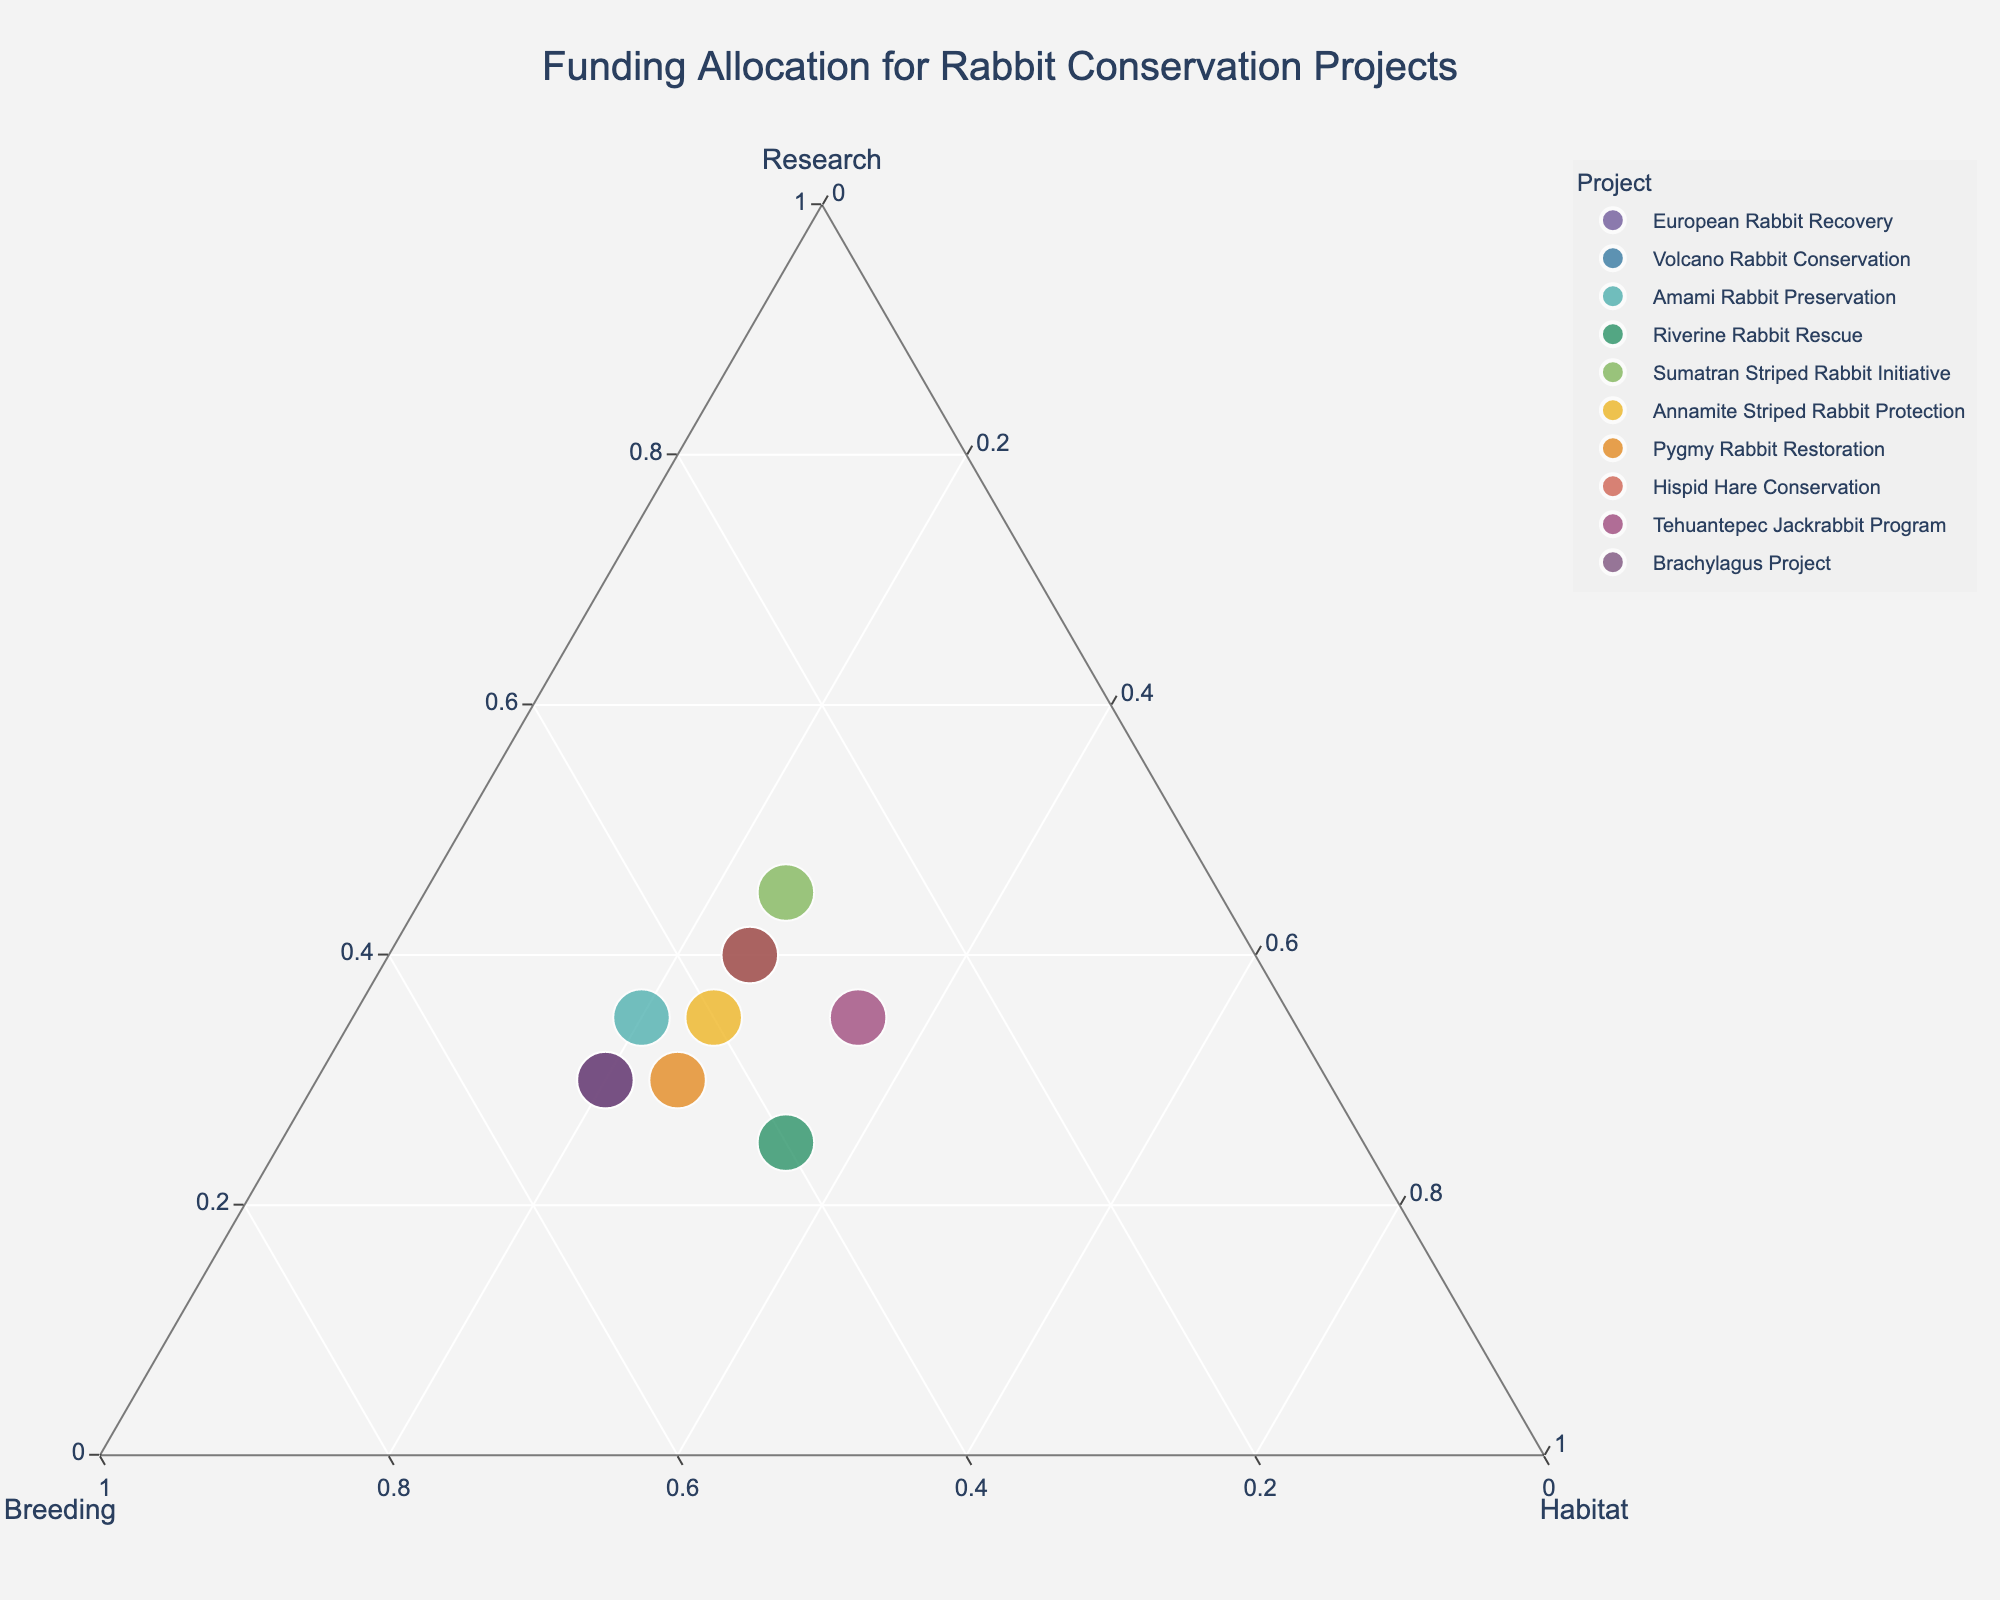what is the title of the plot? The title is generally displayed at the top of the chart. This particular plot is titled "Funding Allocation for Rabbit Conservation Projects".
Answer: Funding Allocation for Rabbit Conservation Projects how many data points are in the figure? By counting the number of points plotted in the Ternary Plot, we find that there are 10 data points.
Answer: 10 which project has the highest percentage of funding allocated to research? By observing the position of points on the ternary plot, the Sumatran Striped Rabbit Initiative has the highest percentage of funding allocated to research, located closer to the Research vertex.
Answer: Sumatran Striped Rabbit Initiative What is the median value for breeding funding allocation? To find the median, list all breeding values (30, 30, 35, 35, 35, 35, 40, 40, 45, 50), sort them, and find the middle number. With 10 data points, the median is the average of 5th and 6th values: (35+35)/2 = 35.
Answer: 35 which two projects have an equal distribution of funding to habitat restoration? By checking the Habitat values, two projects, Riverine Rabbit Rescue and Tehuantepec Jackrabbit Program, both allocate 35% to habitat restoration.
Answer: Riverine Rabbit Rescue, Tehuantepec Jackrabbit Program is there any project with funding equally distributed to research, breeding, and habitat? The plot shows no point near the center of the ternary plot, indicating no project has funding equally distributed across research, breeding, and habitat.
Answer: No which project allocates the least percentage of funding to breeding programs? By observing the points along the Breeding axis, the Sumatran Striped Rabbit Initiative allocates the least funding to breeding, positioned closer to the Research-Habitat edge.
Answer: Sumatran Striped Rabbit Initiative how many projects allocate at least 40% of their funding to research? Checking the axis labels and positions, there are three projects allocating at least 40% to research: Volcano Rabbit Conservation, Hispid Hare Conservation, and Sumatran Striped Rabbit Initiative.
Answer: 3 